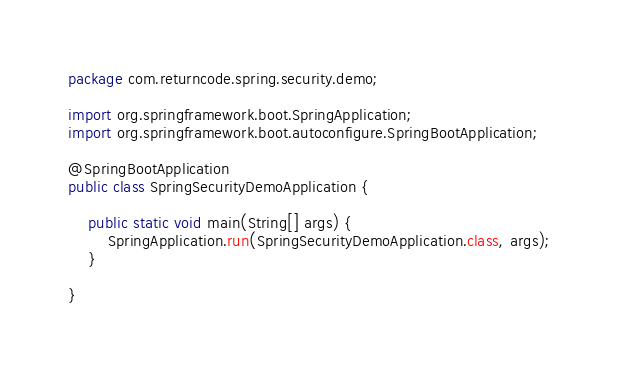<code> <loc_0><loc_0><loc_500><loc_500><_Java_>package com.returncode.spring.security.demo;

import org.springframework.boot.SpringApplication;
import org.springframework.boot.autoconfigure.SpringBootApplication;

@SpringBootApplication
public class SpringSecurityDemoApplication {

	public static void main(String[] args) {
		SpringApplication.run(SpringSecurityDemoApplication.class, args);
	}

}
</code> 